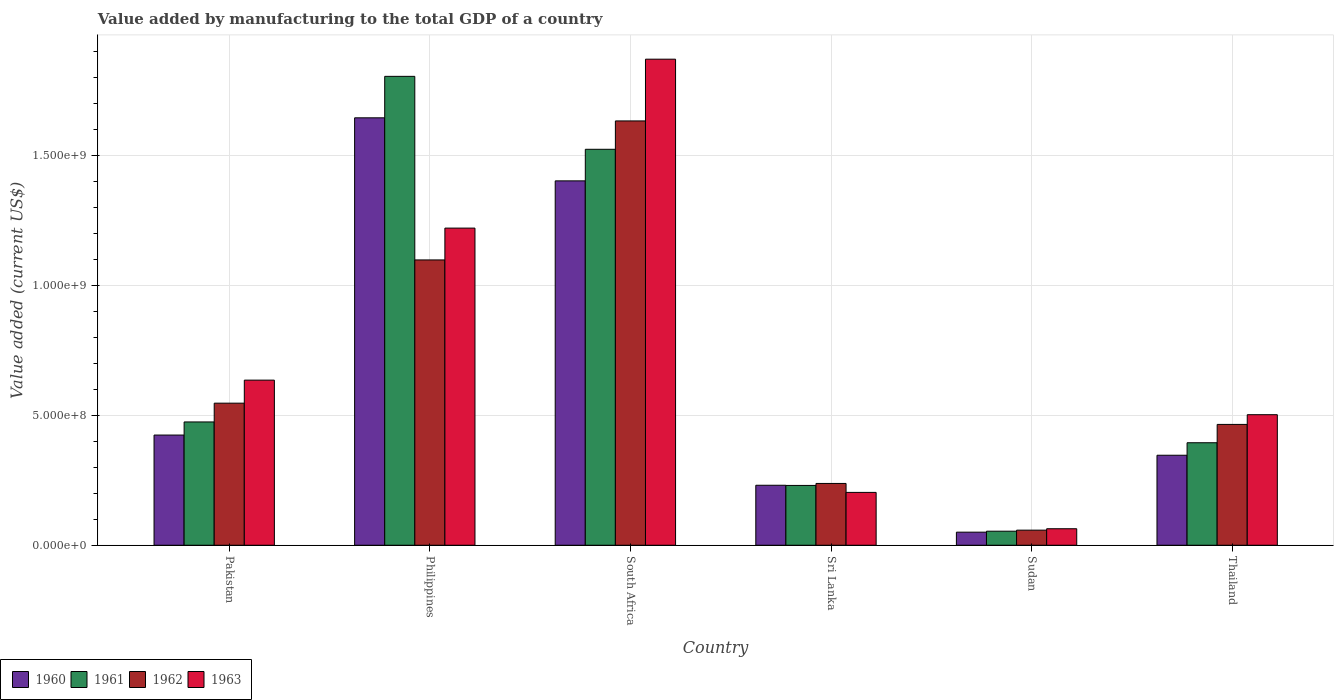How many different coloured bars are there?
Give a very brief answer. 4. How many groups of bars are there?
Make the answer very short. 6. Are the number of bars per tick equal to the number of legend labels?
Keep it short and to the point. Yes. How many bars are there on the 1st tick from the left?
Give a very brief answer. 4. How many bars are there on the 5th tick from the right?
Keep it short and to the point. 4. In how many cases, is the number of bars for a given country not equal to the number of legend labels?
Offer a terse response. 0. What is the value added by manufacturing to the total GDP in 1960 in Thailand?
Provide a succinct answer. 3.46e+08. Across all countries, what is the maximum value added by manufacturing to the total GDP in 1962?
Offer a very short reply. 1.63e+09. Across all countries, what is the minimum value added by manufacturing to the total GDP in 1961?
Offer a terse response. 5.40e+07. In which country was the value added by manufacturing to the total GDP in 1960 minimum?
Give a very brief answer. Sudan. What is the total value added by manufacturing to the total GDP in 1960 in the graph?
Give a very brief answer. 4.10e+09. What is the difference between the value added by manufacturing to the total GDP in 1963 in Philippines and that in Thailand?
Make the answer very short. 7.18e+08. What is the difference between the value added by manufacturing to the total GDP in 1960 in Philippines and the value added by manufacturing to the total GDP in 1962 in Pakistan?
Your answer should be compact. 1.10e+09. What is the average value added by manufacturing to the total GDP in 1961 per country?
Ensure brevity in your answer.  7.46e+08. What is the difference between the value added by manufacturing to the total GDP of/in 1962 and value added by manufacturing to the total GDP of/in 1963 in South Africa?
Provide a succinct answer. -2.37e+08. What is the ratio of the value added by manufacturing to the total GDP in 1960 in Philippines to that in Thailand?
Give a very brief answer. 4.75. Is the value added by manufacturing to the total GDP in 1960 in Philippines less than that in Sudan?
Your response must be concise. No. Is the difference between the value added by manufacturing to the total GDP in 1962 in Pakistan and Philippines greater than the difference between the value added by manufacturing to the total GDP in 1963 in Pakistan and Philippines?
Ensure brevity in your answer.  Yes. What is the difference between the highest and the second highest value added by manufacturing to the total GDP in 1963?
Offer a very short reply. 1.23e+09. What is the difference between the highest and the lowest value added by manufacturing to the total GDP in 1960?
Make the answer very short. 1.59e+09. Is it the case that in every country, the sum of the value added by manufacturing to the total GDP in 1960 and value added by manufacturing to the total GDP in 1961 is greater than the sum of value added by manufacturing to the total GDP in 1962 and value added by manufacturing to the total GDP in 1963?
Ensure brevity in your answer.  No. What does the 1st bar from the left in Pakistan represents?
Provide a short and direct response. 1960. Is it the case that in every country, the sum of the value added by manufacturing to the total GDP in 1962 and value added by manufacturing to the total GDP in 1961 is greater than the value added by manufacturing to the total GDP in 1963?
Keep it short and to the point. Yes. What is the difference between two consecutive major ticks on the Y-axis?
Keep it short and to the point. 5.00e+08. Are the values on the major ticks of Y-axis written in scientific E-notation?
Provide a succinct answer. Yes. Where does the legend appear in the graph?
Your answer should be compact. Bottom left. How are the legend labels stacked?
Give a very brief answer. Horizontal. What is the title of the graph?
Your response must be concise. Value added by manufacturing to the total GDP of a country. What is the label or title of the X-axis?
Make the answer very short. Country. What is the label or title of the Y-axis?
Provide a succinct answer. Value added (current US$). What is the Value added (current US$) in 1960 in Pakistan?
Your response must be concise. 4.24e+08. What is the Value added (current US$) in 1961 in Pakistan?
Offer a very short reply. 4.74e+08. What is the Value added (current US$) in 1962 in Pakistan?
Give a very brief answer. 5.46e+08. What is the Value added (current US$) of 1963 in Pakistan?
Give a very brief answer. 6.35e+08. What is the Value added (current US$) of 1960 in Philippines?
Your answer should be compact. 1.64e+09. What is the Value added (current US$) in 1961 in Philippines?
Give a very brief answer. 1.80e+09. What is the Value added (current US$) of 1962 in Philippines?
Offer a terse response. 1.10e+09. What is the Value added (current US$) in 1963 in Philippines?
Your response must be concise. 1.22e+09. What is the Value added (current US$) in 1960 in South Africa?
Give a very brief answer. 1.40e+09. What is the Value added (current US$) in 1961 in South Africa?
Give a very brief answer. 1.52e+09. What is the Value added (current US$) of 1962 in South Africa?
Your answer should be compact. 1.63e+09. What is the Value added (current US$) of 1963 in South Africa?
Give a very brief answer. 1.87e+09. What is the Value added (current US$) in 1960 in Sri Lanka?
Ensure brevity in your answer.  2.31e+08. What is the Value added (current US$) of 1961 in Sri Lanka?
Provide a short and direct response. 2.30e+08. What is the Value added (current US$) of 1962 in Sri Lanka?
Make the answer very short. 2.38e+08. What is the Value added (current US$) of 1963 in Sri Lanka?
Your answer should be very brief. 2.03e+08. What is the Value added (current US$) in 1960 in Sudan?
Your answer should be very brief. 5.03e+07. What is the Value added (current US$) in 1961 in Sudan?
Offer a terse response. 5.40e+07. What is the Value added (current US$) in 1962 in Sudan?
Provide a short and direct response. 5.80e+07. What is the Value added (current US$) in 1963 in Sudan?
Your answer should be compact. 6.35e+07. What is the Value added (current US$) of 1960 in Thailand?
Offer a terse response. 3.46e+08. What is the Value added (current US$) in 1961 in Thailand?
Ensure brevity in your answer.  3.94e+08. What is the Value added (current US$) of 1962 in Thailand?
Provide a short and direct response. 4.65e+08. What is the Value added (current US$) of 1963 in Thailand?
Provide a short and direct response. 5.02e+08. Across all countries, what is the maximum Value added (current US$) of 1960?
Offer a terse response. 1.64e+09. Across all countries, what is the maximum Value added (current US$) in 1961?
Ensure brevity in your answer.  1.80e+09. Across all countries, what is the maximum Value added (current US$) in 1962?
Give a very brief answer. 1.63e+09. Across all countries, what is the maximum Value added (current US$) of 1963?
Your answer should be compact. 1.87e+09. Across all countries, what is the minimum Value added (current US$) in 1960?
Ensure brevity in your answer.  5.03e+07. Across all countries, what is the minimum Value added (current US$) in 1961?
Your response must be concise. 5.40e+07. Across all countries, what is the minimum Value added (current US$) of 1962?
Make the answer very short. 5.80e+07. Across all countries, what is the minimum Value added (current US$) of 1963?
Offer a very short reply. 6.35e+07. What is the total Value added (current US$) in 1960 in the graph?
Your response must be concise. 4.10e+09. What is the total Value added (current US$) of 1961 in the graph?
Provide a succinct answer. 4.48e+09. What is the total Value added (current US$) in 1962 in the graph?
Your answer should be compact. 4.04e+09. What is the total Value added (current US$) in 1963 in the graph?
Give a very brief answer. 4.49e+09. What is the difference between the Value added (current US$) of 1960 in Pakistan and that in Philippines?
Your response must be concise. -1.22e+09. What is the difference between the Value added (current US$) in 1961 in Pakistan and that in Philippines?
Your response must be concise. -1.33e+09. What is the difference between the Value added (current US$) of 1962 in Pakistan and that in Philippines?
Give a very brief answer. -5.51e+08. What is the difference between the Value added (current US$) in 1963 in Pakistan and that in Philippines?
Give a very brief answer. -5.85e+08. What is the difference between the Value added (current US$) in 1960 in Pakistan and that in South Africa?
Provide a short and direct response. -9.78e+08. What is the difference between the Value added (current US$) in 1961 in Pakistan and that in South Africa?
Offer a very short reply. -1.05e+09. What is the difference between the Value added (current US$) of 1962 in Pakistan and that in South Africa?
Your response must be concise. -1.09e+09. What is the difference between the Value added (current US$) of 1963 in Pakistan and that in South Africa?
Your response must be concise. -1.23e+09. What is the difference between the Value added (current US$) in 1960 in Pakistan and that in Sri Lanka?
Make the answer very short. 1.93e+08. What is the difference between the Value added (current US$) of 1961 in Pakistan and that in Sri Lanka?
Offer a very short reply. 2.44e+08. What is the difference between the Value added (current US$) of 1962 in Pakistan and that in Sri Lanka?
Ensure brevity in your answer.  3.09e+08. What is the difference between the Value added (current US$) in 1963 in Pakistan and that in Sri Lanka?
Offer a terse response. 4.32e+08. What is the difference between the Value added (current US$) in 1960 in Pakistan and that in Sudan?
Your answer should be compact. 3.74e+08. What is the difference between the Value added (current US$) of 1961 in Pakistan and that in Sudan?
Your response must be concise. 4.20e+08. What is the difference between the Value added (current US$) of 1962 in Pakistan and that in Sudan?
Your answer should be very brief. 4.88e+08. What is the difference between the Value added (current US$) in 1963 in Pakistan and that in Sudan?
Give a very brief answer. 5.72e+08. What is the difference between the Value added (current US$) of 1960 in Pakistan and that in Thailand?
Keep it short and to the point. 7.77e+07. What is the difference between the Value added (current US$) of 1961 in Pakistan and that in Thailand?
Your answer should be very brief. 8.00e+07. What is the difference between the Value added (current US$) of 1962 in Pakistan and that in Thailand?
Ensure brevity in your answer.  8.17e+07. What is the difference between the Value added (current US$) in 1963 in Pakistan and that in Thailand?
Provide a succinct answer. 1.33e+08. What is the difference between the Value added (current US$) of 1960 in Philippines and that in South Africa?
Make the answer very short. 2.43e+08. What is the difference between the Value added (current US$) of 1961 in Philippines and that in South Africa?
Your answer should be very brief. 2.80e+08. What is the difference between the Value added (current US$) of 1962 in Philippines and that in South Africa?
Your answer should be compact. -5.35e+08. What is the difference between the Value added (current US$) of 1963 in Philippines and that in South Africa?
Keep it short and to the point. -6.50e+08. What is the difference between the Value added (current US$) of 1960 in Philippines and that in Sri Lanka?
Provide a succinct answer. 1.41e+09. What is the difference between the Value added (current US$) in 1961 in Philippines and that in Sri Lanka?
Your answer should be compact. 1.57e+09. What is the difference between the Value added (current US$) of 1962 in Philippines and that in Sri Lanka?
Make the answer very short. 8.60e+08. What is the difference between the Value added (current US$) in 1963 in Philippines and that in Sri Lanka?
Offer a very short reply. 1.02e+09. What is the difference between the Value added (current US$) of 1960 in Philippines and that in Sudan?
Offer a terse response. 1.59e+09. What is the difference between the Value added (current US$) of 1961 in Philippines and that in Sudan?
Provide a short and direct response. 1.75e+09. What is the difference between the Value added (current US$) of 1962 in Philippines and that in Sudan?
Provide a succinct answer. 1.04e+09. What is the difference between the Value added (current US$) in 1963 in Philippines and that in Sudan?
Your answer should be very brief. 1.16e+09. What is the difference between the Value added (current US$) of 1960 in Philippines and that in Thailand?
Make the answer very short. 1.30e+09. What is the difference between the Value added (current US$) of 1961 in Philippines and that in Thailand?
Provide a succinct answer. 1.41e+09. What is the difference between the Value added (current US$) of 1962 in Philippines and that in Thailand?
Make the answer very short. 6.33e+08. What is the difference between the Value added (current US$) in 1963 in Philippines and that in Thailand?
Provide a short and direct response. 7.18e+08. What is the difference between the Value added (current US$) in 1960 in South Africa and that in Sri Lanka?
Offer a very short reply. 1.17e+09. What is the difference between the Value added (current US$) in 1961 in South Africa and that in Sri Lanka?
Ensure brevity in your answer.  1.29e+09. What is the difference between the Value added (current US$) in 1962 in South Africa and that in Sri Lanka?
Your answer should be compact. 1.39e+09. What is the difference between the Value added (current US$) of 1963 in South Africa and that in Sri Lanka?
Keep it short and to the point. 1.67e+09. What is the difference between the Value added (current US$) in 1960 in South Africa and that in Sudan?
Keep it short and to the point. 1.35e+09. What is the difference between the Value added (current US$) of 1961 in South Africa and that in Sudan?
Your answer should be compact. 1.47e+09. What is the difference between the Value added (current US$) in 1962 in South Africa and that in Sudan?
Provide a short and direct response. 1.57e+09. What is the difference between the Value added (current US$) in 1963 in South Africa and that in Sudan?
Your answer should be compact. 1.81e+09. What is the difference between the Value added (current US$) of 1960 in South Africa and that in Thailand?
Provide a short and direct response. 1.06e+09. What is the difference between the Value added (current US$) in 1961 in South Africa and that in Thailand?
Offer a terse response. 1.13e+09. What is the difference between the Value added (current US$) in 1962 in South Africa and that in Thailand?
Provide a succinct answer. 1.17e+09. What is the difference between the Value added (current US$) in 1963 in South Africa and that in Thailand?
Provide a short and direct response. 1.37e+09. What is the difference between the Value added (current US$) of 1960 in Sri Lanka and that in Sudan?
Provide a short and direct response. 1.80e+08. What is the difference between the Value added (current US$) in 1961 in Sri Lanka and that in Sudan?
Make the answer very short. 1.76e+08. What is the difference between the Value added (current US$) in 1962 in Sri Lanka and that in Sudan?
Provide a succinct answer. 1.80e+08. What is the difference between the Value added (current US$) of 1963 in Sri Lanka and that in Sudan?
Provide a succinct answer. 1.40e+08. What is the difference between the Value added (current US$) in 1960 in Sri Lanka and that in Thailand?
Offer a very short reply. -1.15e+08. What is the difference between the Value added (current US$) in 1961 in Sri Lanka and that in Thailand?
Your response must be concise. -1.64e+08. What is the difference between the Value added (current US$) of 1962 in Sri Lanka and that in Thailand?
Make the answer very short. -2.27e+08. What is the difference between the Value added (current US$) in 1963 in Sri Lanka and that in Thailand?
Offer a very short reply. -2.99e+08. What is the difference between the Value added (current US$) of 1960 in Sudan and that in Thailand?
Your response must be concise. -2.96e+08. What is the difference between the Value added (current US$) in 1961 in Sudan and that in Thailand?
Offer a very short reply. -3.40e+08. What is the difference between the Value added (current US$) in 1962 in Sudan and that in Thailand?
Provide a short and direct response. -4.07e+08. What is the difference between the Value added (current US$) of 1963 in Sudan and that in Thailand?
Offer a terse response. -4.39e+08. What is the difference between the Value added (current US$) in 1960 in Pakistan and the Value added (current US$) in 1961 in Philippines?
Your answer should be very brief. -1.38e+09. What is the difference between the Value added (current US$) of 1960 in Pakistan and the Value added (current US$) of 1962 in Philippines?
Ensure brevity in your answer.  -6.74e+08. What is the difference between the Value added (current US$) in 1960 in Pakistan and the Value added (current US$) in 1963 in Philippines?
Your answer should be very brief. -7.96e+08. What is the difference between the Value added (current US$) of 1961 in Pakistan and the Value added (current US$) of 1962 in Philippines?
Give a very brief answer. -6.23e+08. What is the difference between the Value added (current US$) in 1961 in Pakistan and the Value added (current US$) in 1963 in Philippines?
Offer a terse response. -7.46e+08. What is the difference between the Value added (current US$) in 1962 in Pakistan and the Value added (current US$) in 1963 in Philippines?
Provide a succinct answer. -6.73e+08. What is the difference between the Value added (current US$) in 1960 in Pakistan and the Value added (current US$) in 1961 in South Africa?
Provide a succinct answer. -1.10e+09. What is the difference between the Value added (current US$) in 1960 in Pakistan and the Value added (current US$) in 1962 in South Africa?
Your answer should be compact. -1.21e+09. What is the difference between the Value added (current US$) in 1960 in Pakistan and the Value added (current US$) in 1963 in South Africa?
Give a very brief answer. -1.45e+09. What is the difference between the Value added (current US$) of 1961 in Pakistan and the Value added (current US$) of 1962 in South Africa?
Your response must be concise. -1.16e+09. What is the difference between the Value added (current US$) of 1961 in Pakistan and the Value added (current US$) of 1963 in South Africa?
Give a very brief answer. -1.40e+09. What is the difference between the Value added (current US$) of 1962 in Pakistan and the Value added (current US$) of 1963 in South Africa?
Your answer should be very brief. -1.32e+09. What is the difference between the Value added (current US$) of 1960 in Pakistan and the Value added (current US$) of 1961 in Sri Lanka?
Ensure brevity in your answer.  1.94e+08. What is the difference between the Value added (current US$) in 1960 in Pakistan and the Value added (current US$) in 1962 in Sri Lanka?
Provide a succinct answer. 1.86e+08. What is the difference between the Value added (current US$) of 1960 in Pakistan and the Value added (current US$) of 1963 in Sri Lanka?
Keep it short and to the point. 2.21e+08. What is the difference between the Value added (current US$) of 1961 in Pakistan and the Value added (current US$) of 1962 in Sri Lanka?
Offer a terse response. 2.37e+08. What is the difference between the Value added (current US$) in 1961 in Pakistan and the Value added (current US$) in 1963 in Sri Lanka?
Provide a short and direct response. 2.71e+08. What is the difference between the Value added (current US$) of 1962 in Pakistan and the Value added (current US$) of 1963 in Sri Lanka?
Give a very brief answer. 3.43e+08. What is the difference between the Value added (current US$) of 1960 in Pakistan and the Value added (current US$) of 1961 in Sudan?
Provide a short and direct response. 3.70e+08. What is the difference between the Value added (current US$) in 1960 in Pakistan and the Value added (current US$) in 1962 in Sudan?
Offer a very short reply. 3.66e+08. What is the difference between the Value added (current US$) of 1960 in Pakistan and the Value added (current US$) of 1963 in Sudan?
Offer a terse response. 3.60e+08. What is the difference between the Value added (current US$) of 1961 in Pakistan and the Value added (current US$) of 1962 in Sudan?
Give a very brief answer. 4.16e+08. What is the difference between the Value added (current US$) of 1961 in Pakistan and the Value added (current US$) of 1963 in Sudan?
Provide a short and direct response. 4.11e+08. What is the difference between the Value added (current US$) in 1962 in Pakistan and the Value added (current US$) in 1963 in Sudan?
Make the answer very short. 4.83e+08. What is the difference between the Value added (current US$) in 1960 in Pakistan and the Value added (current US$) in 1961 in Thailand?
Provide a succinct answer. 2.96e+07. What is the difference between the Value added (current US$) in 1960 in Pakistan and the Value added (current US$) in 1962 in Thailand?
Provide a succinct answer. -4.09e+07. What is the difference between the Value added (current US$) of 1960 in Pakistan and the Value added (current US$) of 1963 in Thailand?
Provide a succinct answer. -7.83e+07. What is the difference between the Value added (current US$) in 1961 in Pakistan and the Value added (current US$) in 1962 in Thailand?
Keep it short and to the point. 9.46e+06. What is the difference between the Value added (current US$) in 1961 in Pakistan and the Value added (current US$) in 1963 in Thailand?
Keep it short and to the point. -2.79e+07. What is the difference between the Value added (current US$) in 1962 in Pakistan and the Value added (current US$) in 1963 in Thailand?
Make the answer very short. 4.44e+07. What is the difference between the Value added (current US$) in 1960 in Philippines and the Value added (current US$) in 1961 in South Africa?
Provide a succinct answer. 1.21e+08. What is the difference between the Value added (current US$) of 1960 in Philippines and the Value added (current US$) of 1962 in South Africa?
Ensure brevity in your answer.  1.19e+07. What is the difference between the Value added (current US$) of 1960 in Philippines and the Value added (current US$) of 1963 in South Africa?
Make the answer very short. -2.26e+08. What is the difference between the Value added (current US$) in 1961 in Philippines and the Value added (current US$) in 1962 in South Africa?
Offer a very short reply. 1.71e+08. What is the difference between the Value added (current US$) of 1961 in Philippines and the Value added (current US$) of 1963 in South Africa?
Your answer should be very brief. -6.61e+07. What is the difference between the Value added (current US$) of 1962 in Philippines and the Value added (current US$) of 1963 in South Africa?
Provide a succinct answer. -7.72e+08. What is the difference between the Value added (current US$) of 1960 in Philippines and the Value added (current US$) of 1961 in Sri Lanka?
Ensure brevity in your answer.  1.41e+09. What is the difference between the Value added (current US$) in 1960 in Philippines and the Value added (current US$) in 1962 in Sri Lanka?
Give a very brief answer. 1.41e+09. What is the difference between the Value added (current US$) of 1960 in Philippines and the Value added (current US$) of 1963 in Sri Lanka?
Give a very brief answer. 1.44e+09. What is the difference between the Value added (current US$) in 1961 in Philippines and the Value added (current US$) in 1962 in Sri Lanka?
Your answer should be compact. 1.57e+09. What is the difference between the Value added (current US$) of 1961 in Philippines and the Value added (current US$) of 1963 in Sri Lanka?
Keep it short and to the point. 1.60e+09. What is the difference between the Value added (current US$) in 1962 in Philippines and the Value added (current US$) in 1963 in Sri Lanka?
Your answer should be very brief. 8.94e+08. What is the difference between the Value added (current US$) of 1960 in Philippines and the Value added (current US$) of 1961 in Sudan?
Make the answer very short. 1.59e+09. What is the difference between the Value added (current US$) in 1960 in Philippines and the Value added (current US$) in 1962 in Sudan?
Your answer should be very brief. 1.59e+09. What is the difference between the Value added (current US$) in 1960 in Philippines and the Value added (current US$) in 1963 in Sudan?
Your answer should be very brief. 1.58e+09. What is the difference between the Value added (current US$) in 1961 in Philippines and the Value added (current US$) in 1962 in Sudan?
Your answer should be compact. 1.75e+09. What is the difference between the Value added (current US$) of 1961 in Philippines and the Value added (current US$) of 1963 in Sudan?
Keep it short and to the point. 1.74e+09. What is the difference between the Value added (current US$) of 1962 in Philippines and the Value added (current US$) of 1963 in Sudan?
Your response must be concise. 1.03e+09. What is the difference between the Value added (current US$) of 1960 in Philippines and the Value added (current US$) of 1961 in Thailand?
Make the answer very short. 1.25e+09. What is the difference between the Value added (current US$) of 1960 in Philippines and the Value added (current US$) of 1962 in Thailand?
Ensure brevity in your answer.  1.18e+09. What is the difference between the Value added (current US$) of 1960 in Philippines and the Value added (current US$) of 1963 in Thailand?
Provide a succinct answer. 1.14e+09. What is the difference between the Value added (current US$) in 1961 in Philippines and the Value added (current US$) in 1962 in Thailand?
Offer a very short reply. 1.34e+09. What is the difference between the Value added (current US$) in 1961 in Philippines and the Value added (current US$) in 1963 in Thailand?
Offer a terse response. 1.30e+09. What is the difference between the Value added (current US$) in 1962 in Philippines and the Value added (current US$) in 1963 in Thailand?
Your answer should be compact. 5.95e+08. What is the difference between the Value added (current US$) in 1960 in South Africa and the Value added (current US$) in 1961 in Sri Lanka?
Keep it short and to the point. 1.17e+09. What is the difference between the Value added (current US$) of 1960 in South Africa and the Value added (current US$) of 1962 in Sri Lanka?
Provide a succinct answer. 1.16e+09. What is the difference between the Value added (current US$) in 1960 in South Africa and the Value added (current US$) in 1963 in Sri Lanka?
Provide a succinct answer. 1.20e+09. What is the difference between the Value added (current US$) of 1961 in South Africa and the Value added (current US$) of 1962 in Sri Lanka?
Make the answer very short. 1.29e+09. What is the difference between the Value added (current US$) in 1961 in South Africa and the Value added (current US$) in 1963 in Sri Lanka?
Make the answer very short. 1.32e+09. What is the difference between the Value added (current US$) of 1962 in South Africa and the Value added (current US$) of 1963 in Sri Lanka?
Provide a short and direct response. 1.43e+09. What is the difference between the Value added (current US$) of 1960 in South Africa and the Value added (current US$) of 1961 in Sudan?
Your answer should be compact. 1.35e+09. What is the difference between the Value added (current US$) in 1960 in South Africa and the Value added (current US$) in 1962 in Sudan?
Provide a short and direct response. 1.34e+09. What is the difference between the Value added (current US$) of 1960 in South Africa and the Value added (current US$) of 1963 in Sudan?
Keep it short and to the point. 1.34e+09. What is the difference between the Value added (current US$) in 1961 in South Africa and the Value added (current US$) in 1962 in Sudan?
Make the answer very short. 1.46e+09. What is the difference between the Value added (current US$) in 1961 in South Africa and the Value added (current US$) in 1963 in Sudan?
Offer a very short reply. 1.46e+09. What is the difference between the Value added (current US$) of 1962 in South Africa and the Value added (current US$) of 1963 in Sudan?
Offer a very short reply. 1.57e+09. What is the difference between the Value added (current US$) of 1960 in South Africa and the Value added (current US$) of 1961 in Thailand?
Provide a short and direct response. 1.01e+09. What is the difference between the Value added (current US$) in 1960 in South Africa and the Value added (current US$) in 1962 in Thailand?
Offer a very short reply. 9.37e+08. What is the difference between the Value added (current US$) of 1960 in South Africa and the Value added (current US$) of 1963 in Thailand?
Your answer should be very brief. 8.99e+08. What is the difference between the Value added (current US$) in 1961 in South Africa and the Value added (current US$) in 1962 in Thailand?
Provide a short and direct response. 1.06e+09. What is the difference between the Value added (current US$) in 1961 in South Africa and the Value added (current US$) in 1963 in Thailand?
Provide a short and direct response. 1.02e+09. What is the difference between the Value added (current US$) in 1962 in South Africa and the Value added (current US$) in 1963 in Thailand?
Offer a very short reply. 1.13e+09. What is the difference between the Value added (current US$) in 1960 in Sri Lanka and the Value added (current US$) in 1961 in Sudan?
Offer a very short reply. 1.77e+08. What is the difference between the Value added (current US$) of 1960 in Sri Lanka and the Value added (current US$) of 1962 in Sudan?
Offer a very short reply. 1.73e+08. What is the difference between the Value added (current US$) of 1960 in Sri Lanka and the Value added (current US$) of 1963 in Sudan?
Provide a succinct answer. 1.67e+08. What is the difference between the Value added (current US$) of 1961 in Sri Lanka and the Value added (current US$) of 1962 in Sudan?
Ensure brevity in your answer.  1.72e+08. What is the difference between the Value added (current US$) in 1961 in Sri Lanka and the Value added (current US$) in 1963 in Sudan?
Ensure brevity in your answer.  1.67e+08. What is the difference between the Value added (current US$) in 1962 in Sri Lanka and the Value added (current US$) in 1963 in Sudan?
Provide a succinct answer. 1.74e+08. What is the difference between the Value added (current US$) in 1960 in Sri Lanka and the Value added (current US$) in 1961 in Thailand?
Your answer should be very brief. -1.64e+08. What is the difference between the Value added (current US$) in 1960 in Sri Lanka and the Value added (current US$) in 1962 in Thailand?
Offer a very short reply. -2.34e+08. What is the difference between the Value added (current US$) in 1960 in Sri Lanka and the Value added (current US$) in 1963 in Thailand?
Your answer should be very brief. -2.71e+08. What is the difference between the Value added (current US$) in 1961 in Sri Lanka and the Value added (current US$) in 1962 in Thailand?
Offer a terse response. -2.35e+08. What is the difference between the Value added (current US$) of 1961 in Sri Lanka and the Value added (current US$) of 1963 in Thailand?
Make the answer very short. -2.72e+08. What is the difference between the Value added (current US$) in 1962 in Sri Lanka and the Value added (current US$) in 1963 in Thailand?
Offer a very short reply. -2.64e+08. What is the difference between the Value added (current US$) in 1960 in Sudan and the Value added (current US$) in 1961 in Thailand?
Your answer should be very brief. -3.44e+08. What is the difference between the Value added (current US$) in 1960 in Sudan and the Value added (current US$) in 1962 in Thailand?
Your answer should be compact. -4.14e+08. What is the difference between the Value added (current US$) in 1960 in Sudan and the Value added (current US$) in 1963 in Thailand?
Make the answer very short. -4.52e+08. What is the difference between the Value added (current US$) in 1961 in Sudan and the Value added (current US$) in 1962 in Thailand?
Provide a succinct answer. -4.11e+08. What is the difference between the Value added (current US$) of 1961 in Sudan and the Value added (current US$) of 1963 in Thailand?
Your answer should be very brief. -4.48e+08. What is the difference between the Value added (current US$) of 1962 in Sudan and the Value added (current US$) of 1963 in Thailand?
Your answer should be very brief. -4.44e+08. What is the average Value added (current US$) in 1960 per country?
Make the answer very short. 6.83e+08. What is the average Value added (current US$) of 1961 per country?
Offer a terse response. 7.46e+08. What is the average Value added (current US$) of 1962 per country?
Your response must be concise. 6.73e+08. What is the average Value added (current US$) of 1963 per country?
Your response must be concise. 7.49e+08. What is the difference between the Value added (current US$) of 1960 and Value added (current US$) of 1961 in Pakistan?
Your response must be concise. -5.04e+07. What is the difference between the Value added (current US$) of 1960 and Value added (current US$) of 1962 in Pakistan?
Your response must be concise. -1.23e+08. What is the difference between the Value added (current US$) in 1960 and Value added (current US$) in 1963 in Pakistan?
Offer a terse response. -2.11e+08. What is the difference between the Value added (current US$) of 1961 and Value added (current US$) of 1962 in Pakistan?
Your response must be concise. -7.22e+07. What is the difference between the Value added (current US$) in 1961 and Value added (current US$) in 1963 in Pakistan?
Offer a terse response. -1.61e+08. What is the difference between the Value added (current US$) in 1962 and Value added (current US$) in 1963 in Pakistan?
Your answer should be very brief. -8.86e+07. What is the difference between the Value added (current US$) of 1960 and Value added (current US$) of 1961 in Philippines?
Provide a succinct answer. -1.59e+08. What is the difference between the Value added (current US$) of 1960 and Value added (current US$) of 1962 in Philippines?
Offer a terse response. 5.47e+08. What is the difference between the Value added (current US$) in 1960 and Value added (current US$) in 1963 in Philippines?
Ensure brevity in your answer.  4.24e+08. What is the difference between the Value added (current US$) of 1961 and Value added (current US$) of 1962 in Philippines?
Make the answer very short. 7.06e+08. What is the difference between the Value added (current US$) in 1961 and Value added (current US$) in 1963 in Philippines?
Your response must be concise. 5.84e+08. What is the difference between the Value added (current US$) of 1962 and Value added (current US$) of 1963 in Philippines?
Give a very brief answer. -1.22e+08. What is the difference between the Value added (current US$) in 1960 and Value added (current US$) in 1961 in South Africa?
Your response must be concise. -1.21e+08. What is the difference between the Value added (current US$) of 1960 and Value added (current US$) of 1962 in South Africa?
Give a very brief answer. -2.31e+08. What is the difference between the Value added (current US$) of 1960 and Value added (current US$) of 1963 in South Africa?
Ensure brevity in your answer.  -4.68e+08. What is the difference between the Value added (current US$) of 1961 and Value added (current US$) of 1962 in South Africa?
Make the answer very short. -1.09e+08. What is the difference between the Value added (current US$) of 1961 and Value added (current US$) of 1963 in South Africa?
Give a very brief answer. -3.47e+08. What is the difference between the Value added (current US$) in 1962 and Value added (current US$) in 1963 in South Africa?
Make the answer very short. -2.37e+08. What is the difference between the Value added (current US$) in 1960 and Value added (current US$) in 1961 in Sri Lanka?
Offer a terse response. 6.30e+05. What is the difference between the Value added (current US$) in 1960 and Value added (current US$) in 1962 in Sri Lanka?
Your answer should be compact. -6.98e+06. What is the difference between the Value added (current US$) in 1960 and Value added (current US$) in 1963 in Sri Lanka?
Offer a very short reply. 2.75e+07. What is the difference between the Value added (current US$) of 1961 and Value added (current US$) of 1962 in Sri Lanka?
Give a very brief answer. -7.61e+06. What is the difference between the Value added (current US$) of 1961 and Value added (current US$) of 1963 in Sri Lanka?
Offer a terse response. 2.68e+07. What is the difference between the Value added (current US$) in 1962 and Value added (current US$) in 1963 in Sri Lanka?
Offer a very short reply. 3.45e+07. What is the difference between the Value added (current US$) in 1960 and Value added (current US$) in 1961 in Sudan?
Give a very brief answer. -3.73e+06. What is the difference between the Value added (current US$) in 1960 and Value added (current US$) in 1962 in Sudan?
Keep it short and to the point. -7.75e+06. What is the difference between the Value added (current US$) of 1960 and Value added (current US$) of 1963 in Sudan?
Ensure brevity in your answer.  -1.32e+07. What is the difference between the Value added (current US$) in 1961 and Value added (current US$) in 1962 in Sudan?
Make the answer very short. -4.02e+06. What is the difference between the Value added (current US$) of 1961 and Value added (current US$) of 1963 in Sudan?
Your response must be concise. -9.48e+06. What is the difference between the Value added (current US$) in 1962 and Value added (current US$) in 1963 in Sudan?
Your answer should be very brief. -5.46e+06. What is the difference between the Value added (current US$) in 1960 and Value added (current US$) in 1961 in Thailand?
Offer a very short reply. -4.81e+07. What is the difference between the Value added (current US$) in 1960 and Value added (current US$) in 1962 in Thailand?
Keep it short and to the point. -1.19e+08. What is the difference between the Value added (current US$) in 1960 and Value added (current US$) in 1963 in Thailand?
Offer a terse response. -1.56e+08. What is the difference between the Value added (current US$) in 1961 and Value added (current US$) in 1962 in Thailand?
Keep it short and to the point. -7.05e+07. What is the difference between the Value added (current US$) in 1961 and Value added (current US$) in 1963 in Thailand?
Ensure brevity in your answer.  -1.08e+08. What is the difference between the Value added (current US$) of 1962 and Value added (current US$) of 1963 in Thailand?
Provide a short and direct response. -3.73e+07. What is the ratio of the Value added (current US$) in 1960 in Pakistan to that in Philippines?
Your response must be concise. 0.26. What is the ratio of the Value added (current US$) of 1961 in Pakistan to that in Philippines?
Make the answer very short. 0.26. What is the ratio of the Value added (current US$) in 1962 in Pakistan to that in Philippines?
Give a very brief answer. 0.5. What is the ratio of the Value added (current US$) of 1963 in Pakistan to that in Philippines?
Keep it short and to the point. 0.52. What is the ratio of the Value added (current US$) in 1960 in Pakistan to that in South Africa?
Offer a very short reply. 0.3. What is the ratio of the Value added (current US$) in 1961 in Pakistan to that in South Africa?
Provide a succinct answer. 0.31. What is the ratio of the Value added (current US$) in 1962 in Pakistan to that in South Africa?
Keep it short and to the point. 0.33. What is the ratio of the Value added (current US$) of 1963 in Pakistan to that in South Africa?
Offer a very short reply. 0.34. What is the ratio of the Value added (current US$) in 1960 in Pakistan to that in Sri Lanka?
Your answer should be compact. 1.84. What is the ratio of the Value added (current US$) of 1961 in Pakistan to that in Sri Lanka?
Your response must be concise. 2.06. What is the ratio of the Value added (current US$) in 1962 in Pakistan to that in Sri Lanka?
Your response must be concise. 2.3. What is the ratio of the Value added (current US$) of 1963 in Pakistan to that in Sri Lanka?
Your response must be concise. 3.13. What is the ratio of the Value added (current US$) in 1960 in Pakistan to that in Sudan?
Keep it short and to the point. 8.43. What is the ratio of the Value added (current US$) of 1961 in Pakistan to that in Sudan?
Offer a very short reply. 8.78. What is the ratio of the Value added (current US$) in 1962 in Pakistan to that in Sudan?
Give a very brief answer. 9.42. What is the ratio of the Value added (current US$) in 1963 in Pakistan to that in Sudan?
Your answer should be very brief. 10.01. What is the ratio of the Value added (current US$) in 1960 in Pakistan to that in Thailand?
Make the answer very short. 1.22. What is the ratio of the Value added (current US$) in 1961 in Pakistan to that in Thailand?
Your response must be concise. 1.2. What is the ratio of the Value added (current US$) of 1962 in Pakistan to that in Thailand?
Give a very brief answer. 1.18. What is the ratio of the Value added (current US$) of 1963 in Pakistan to that in Thailand?
Your answer should be very brief. 1.26. What is the ratio of the Value added (current US$) of 1960 in Philippines to that in South Africa?
Ensure brevity in your answer.  1.17. What is the ratio of the Value added (current US$) of 1961 in Philippines to that in South Africa?
Offer a very short reply. 1.18. What is the ratio of the Value added (current US$) in 1962 in Philippines to that in South Africa?
Provide a short and direct response. 0.67. What is the ratio of the Value added (current US$) of 1963 in Philippines to that in South Africa?
Your answer should be compact. 0.65. What is the ratio of the Value added (current US$) of 1960 in Philippines to that in Sri Lanka?
Your answer should be compact. 7.13. What is the ratio of the Value added (current US$) in 1961 in Philippines to that in Sri Lanka?
Give a very brief answer. 7.84. What is the ratio of the Value added (current US$) of 1962 in Philippines to that in Sri Lanka?
Give a very brief answer. 4.62. What is the ratio of the Value added (current US$) of 1963 in Philippines to that in Sri Lanka?
Make the answer very short. 6. What is the ratio of the Value added (current US$) of 1960 in Philippines to that in Sudan?
Your response must be concise. 32.71. What is the ratio of the Value added (current US$) in 1961 in Philippines to that in Sudan?
Your answer should be very brief. 33.4. What is the ratio of the Value added (current US$) of 1962 in Philippines to that in Sudan?
Your answer should be compact. 18.91. What is the ratio of the Value added (current US$) in 1963 in Philippines to that in Sudan?
Provide a succinct answer. 19.22. What is the ratio of the Value added (current US$) in 1960 in Philippines to that in Thailand?
Keep it short and to the point. 4.75. What is the ratio of the Value added (current US$) in 1961 in Philippines to that in Thailand?
Offer a very short reply. 4.57. What is the ratio of the Value added (current US$) of 1962 in Philippines to that in Thailand?
Your response must be concise. 2.36. What is the ratio of the Value added (current US$) of 1963 in Philippines to that in Thailand?
Your answer should be very brief. 2.43. What is the ratio of the Value added (current US$) of 1960 in South Africa to that in Sri Lanka?
Your response must be concise. 6.08. What is the ratio of the Value added (current US$) of 1961 in South Africa to that in Sri Lanka?
Give a very brief answer. 6.62. What is the ratio of the Value added (current US$) in 1962 in South Africa to that in Sri Lanka?
Give a very brief answer. 6.87. What is the ratio of the Value added (current US$) in 1963 in South Africa to that in Sri Lanka?
Provide a short and direct response. 9.2. What is the ratio of the Value added (current US$) in 1960 in South Africa to that in Sudan?
Offer a terse response. 27.88. What is the ratio of the Value added (current US$) of 1961 in South Africa to that in Sudan?
Provide a succinct answer. 28.21. What is the ratio of the Value added (current US$) of 1962 in South Africa to that in Sudan?
Offer a very short reply. 28.13. What is the ratio of the Value added (current US$) of 1963 in South Africa to that in Sudan?
Your response must be concise. 29.45. What is the ratio of the Value added (current US$) in 1960 in South Africa to that in Thailand?
Ensure brevity in your answer.  4.05. What is the ratio of the Value added (current US$) in 1961 in South Africa to that in Thailand?
Keep it short and to the point. 3.86. What is the ratio of the Value added (current US$) of 1962 in South Africa to that in Thailand?
Make the answer very short. 3.51. What is the ratio of the Value added (current US$) of 1963 in South Africa to that in Thailand?
Keep it short and to the point. 3.72. What is the ratio of the Value added (current US$) in 1960 in Sri Lanka to that in Sudan?
Provide a short and direct response. 4.59. What is the ratio of the Value added (current US$) in 1961 in Sri Lanka to that in Sudan?
Give a very brief answer. 4.26. What is the ratio of the Value added (current US$) of 1962 in Sri Lanka to that in Sudan?
Provide a succinct answer. 4.1. What is the ratio of the Value added (current US$) of 1963 in Sri Lanka to that in Sudan?
Make the answer very short. 3.2. What is the ratio of the Value added (current US$) in 1960 in Sri Lanka to that in Thailand?
Provide a short and direct response. 0.67. What is the ratio of the Value added (current US$) in 1961 in Sri Lanka to that in Thailand?
Your response must be concise. 0.58. What is the ratio of the Value added (current US$) in 1962 in Sri Lanka to that in Thailand?
Provide a short and direct response. 0.51. What is the ratio of the Value added (current US$) of 1963 in Sri Lanka to that in Thailand?
Provide a short and direct response. 0.4. What is the ratio of the Value added (current US$) of 1960 in Sudan to that in Thailand?
Give a very brief answer. 0.15. What is the ratio of the Value added (current US$) of 1961 in Sudan to that in Thailand?
Keep it short and to the point. 0.14. What is the ratio of the Value added (current US$) of 1962 in Sudan to that in Thailand?
Your answer should be compact. 0.12. What is the ratio of the Value added (current US$) in 1963 in Sudan to that in Thailand?
Offer a very short reply. 0.13. What is the difference between the highest and the second highest Value added (current US$) of 1960?
Your answer should be very brief. 2.43e+08. What is the difference between the highest and the second highest Value added (current US$) in 1961?
Your answer should be compact. 2.80e+08. What is the difference between the highest and the second highest Value added (current US$) in 1962?
Your answer should be very brief. 5.35e+08. What is the difference between the highest and the second highest Value added (current US$) of 1963?
Make the answer very short. 6.50e+08. What is the difference between the highest and the lowest Value added (current US$) of 1960?
Give a very brief answer. 1.59e+09. What is the difference between the highest and the lowest Value added (current US$) of 1961?
Provide a short and direct response. 1.75e+09. What is the difference between the highest and the lowest Value added (current US$) in 1962?
Your answer should be compact. 1.57e+09. What is the difference between the highest and the lowest Value added (current US$) in 1963?
Offer a terse response. 1.81e+09. 